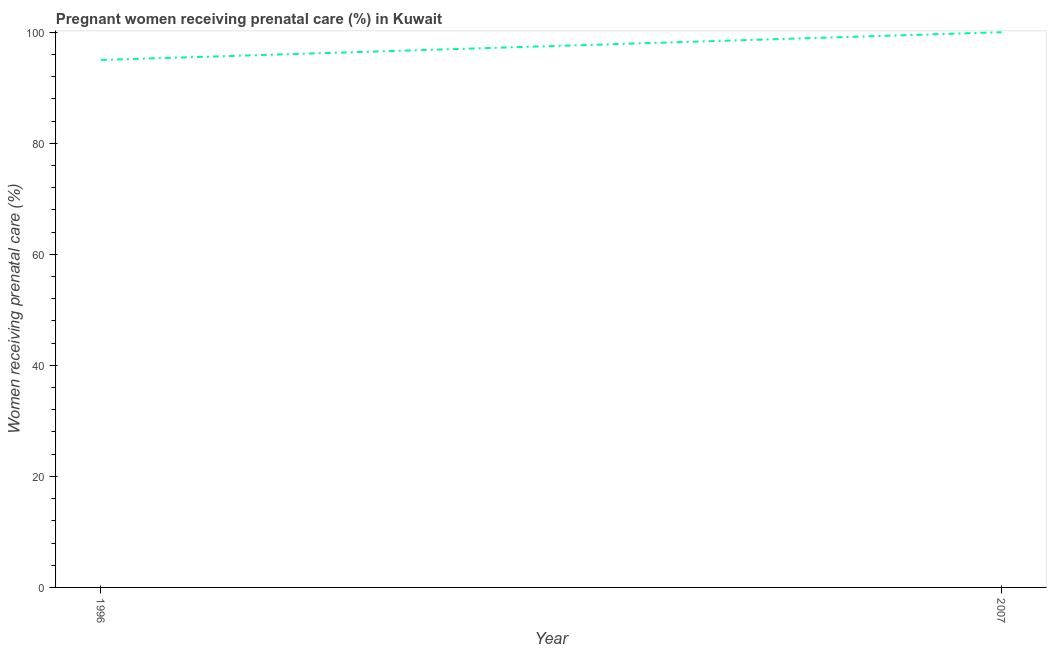What is the percentage of pregnant women receiving prenatal care in 2007?
Your answer should be very brief. 100. Across all years, what is the maximum percentage of pregnant women receiving prenatal care?
Your answer should be compact. 100. Across all years, what is the minimum percentage of pregnant women receiving prenatal care?
Your response must be concise. 95. In which year was the percentage of pregnant women receiving prenatal care maximum?
Your response must be concise. 2007. In which year was the percentage of pregnant women receiving prenatal care minimum?
Your answer should be very brief. 1996. What is the sum of the percentage of pregnant women receiving prenatal care?
Your answer should be very brief. 195. What is the difference between the percentage of pregnant women receiving prenatal care in 1996 and 2007?
Give a very brief answer. -5. What is the average percentage of pregnant women receiving prenatal care per year?
Provide a succinct answer. 97.5. What is the median percentage of pregnant women receiving prenatal care?
Provide a short and direct response. 97.5. In how many years, is the percentage of pregnant women receiving prenatal care greater than 92 %?
Make the answer very short. 2. Do a majority of the years between 1996 and 2007 (inclusive) have percentage of pregnant women receiving prenatal care greater than 96 %?
Your response must be concise. No. What is the ratio of the percentage of pregnant women receiving prenatal care in 1996 to that in 2007?
Keep it short and to the point. 0.95. Is the percentage of pregnant women receiving prenatal care in 1996 less than that in 2007?
Keep it short and to the point. Yes. In how many years, is the percentage of pregnant women receiving prenatal care greater than the average percentage of pregnant women receiving prenatal care taken over all years?
Your answer should be very brief. 1. How many years are there in the graph?
Ensure brevity in your answer.  2. Are the values on the major ticks of Y-axis written in scientific E-notation?
Offer a very short reply. No. What is the title of the graph?
Your answer should be compact. Pregnant women receiving prenatal care (%) in Kuwait. What is the label or title of the Y-axis?
Your answer should be very brief. Women receiving prenatal care (%). What is the Women receiving prenatal care (%) in 1996?
Give a very brief answer. 95. What is the Women receiving prenatal care (%) of 2007?
Give a very brief answer. 100. What is the difference between the Women receiving prenatal care (%) in 1996 and 2007?
Ensure brevity in your answer.  -5. 